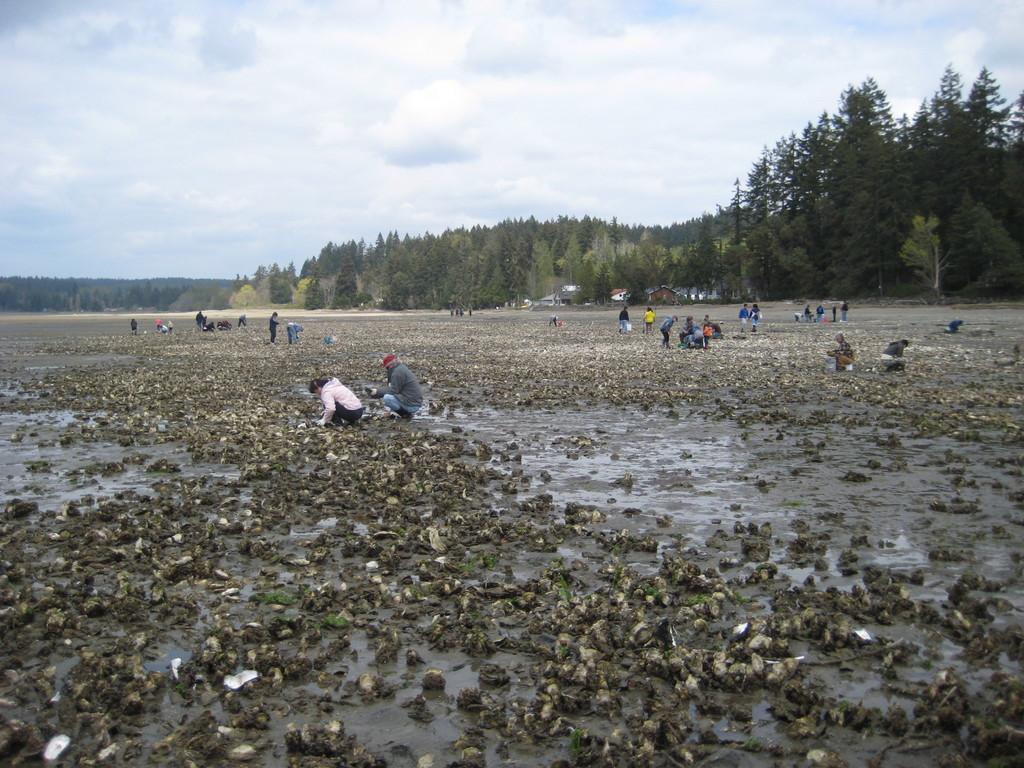How many people can be seen in the image? There are people in the image, but the exact number is not specified. What type of surface is visible beneath the people? There is ground visible in the image. What other items can be seen in the image besides the people? There are objects in the image. What can be seen in the distance behind the people? There are trees, houses, and the sky visible in the background of the image. Where are the tomatoes growing in the image? There are no tomatoes present in the image. What type of animal can be seen interacting with the people in the image? There is no animal present in the image; only people, ground, objects, trees, houses, and the sky are visible. 